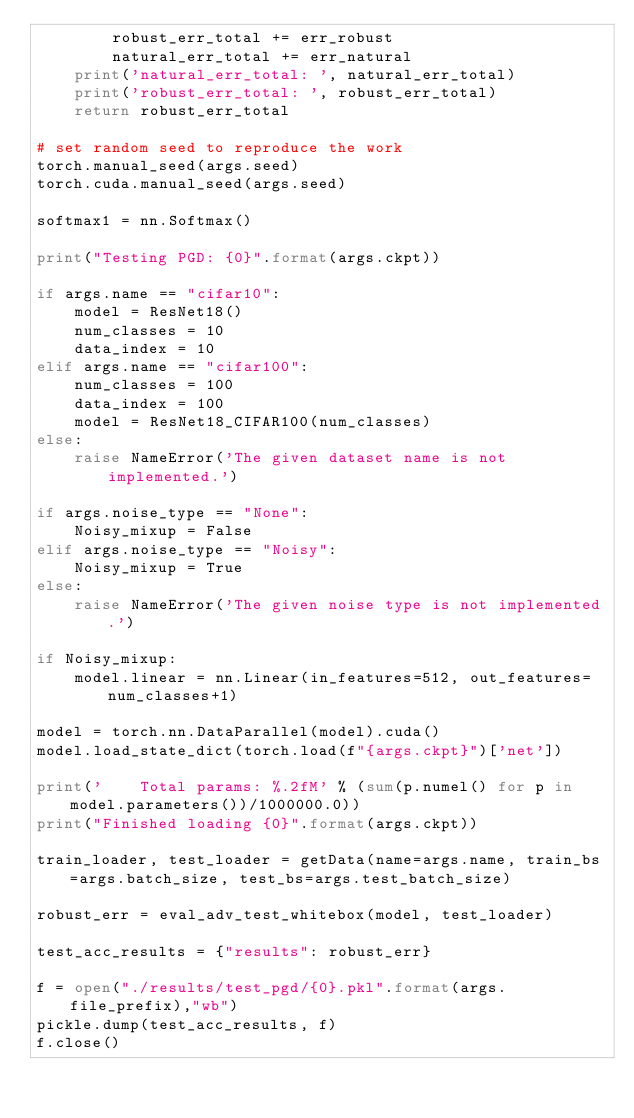Convert code to text. <code><loc_0><loc_0><loc_500><loc_500><_Python_>        robust_err_total += err_robust
        natural_err_total += err_natural
    print('natural_err_total: ', natural_err_total)
    print('robust_err_total: ', robust_err_total)
    return robust_err_total

# set random seed to reproduce the work
torch.manual_seed(args.seed)
torch.cuda.manual_seed(args.seed)

softmax1 = nn.Softmax()
        
print("Testing PGD: {0}".format(args.ckpt))

if args.name == "cifar10":
    model = ResNet18()
    num_classes = 10
    data_index = 10
elif args.name == "cifar100":
    num_classes = 100
    data_index = 100
    model = ResNet18_CIFAR100(num_classes)
else:
    raise NameError('The given dataset name is not implemented.')

if args.noise_type == "None":
    Noisy_mixup = False
elif args.noise_type == "Noisy":
    Noisy_mixup = True
else:
    raise NameError('The given noise type is not implemented.')
    
if Noisy_mixup:
    model.linear = nn.Linear(in_features=512, out_features=num_classes+1)

model = torch.nn.DataParallel(model).cuda()
model.load_state_dict(torch.load(f"{args.ckpt}")['net'])

print('    Total params: %.2fM' % (sum(p.numel() for p in model.parameters())/1000000.0))
print("Finished loading {0}".format(args.ckpt))

train_loader, test_loader = getData(name=args.name, train_bs=args.batch_size, test_bs=args.test_batch_size)

robust_err = eval_adv_test_whitebox(model, test_loader)

test_acc_results = {"results": robust_err}

f = open("./results/test_pgd/{0}.pkl".format(args.file_prefix),"wb")
pickle.dump(test_acc_results, f)
f.close()</code> 